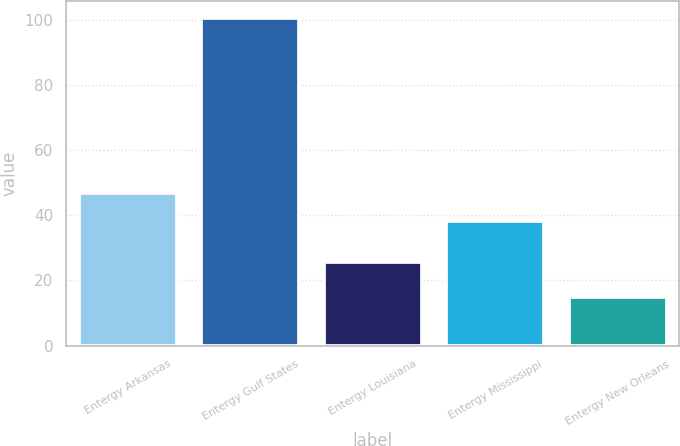Convert chart to OTSL. <chart><loc_0><loc_0><loc_500><loc_500><bar_chart><fcel>Entergy Arkansas<fcel>Entergy Gulf States<fcel>Entergy Louisiana<fcel>Entergy Mississippi<fcel>Entergy New Orleans<nl><fcel>46.77<fcel>100.6<fcel>25.6<fcel>38.2<fcel>14.9<nl></chart> 